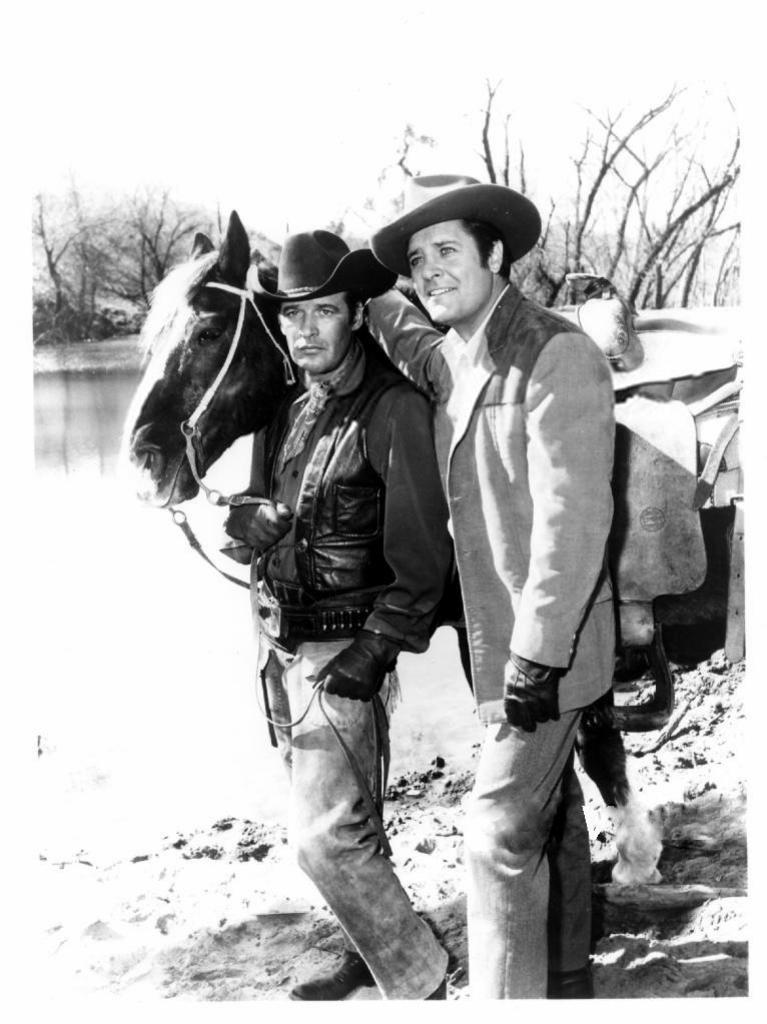In one or two sentences, can you explain what this image depicts? As we can see in the image there is a sky, horse, water and two people standing. 